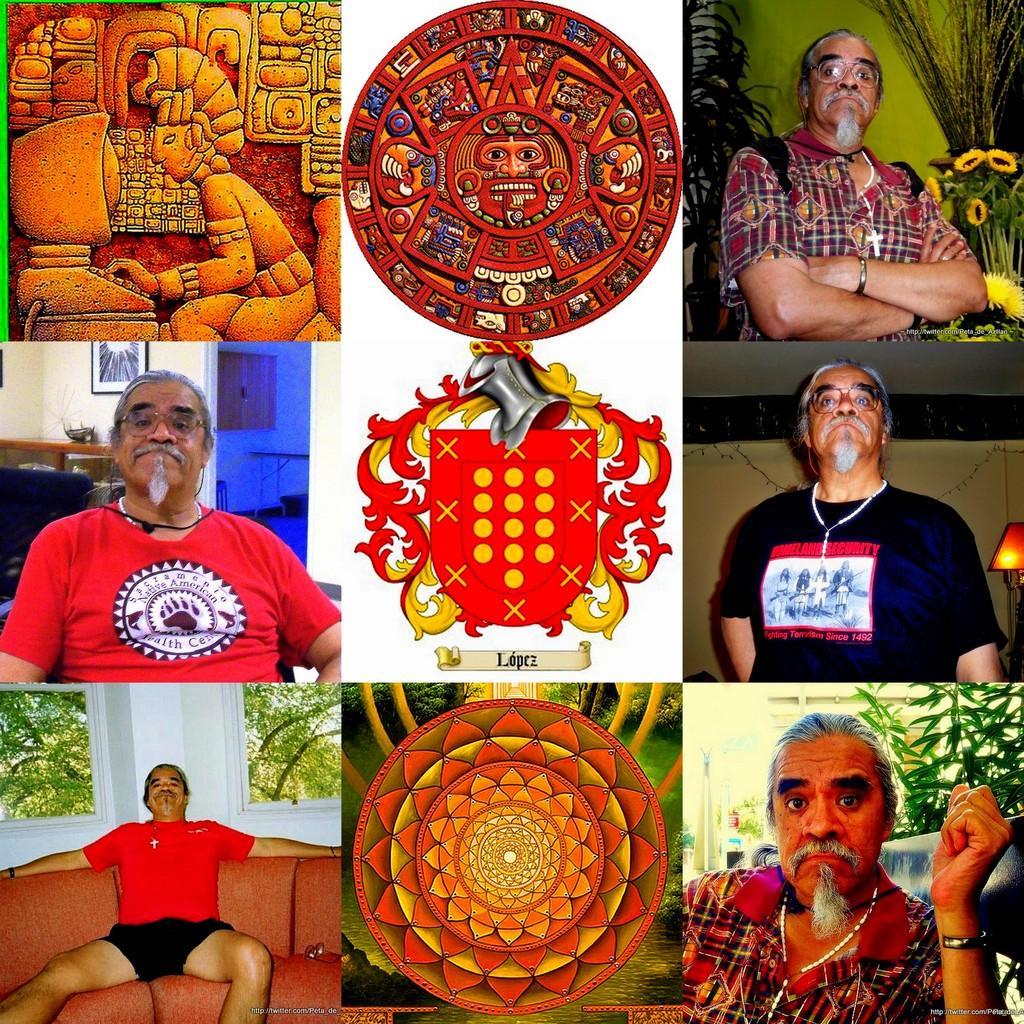Please provide a concise description of this image. This looks like an edited image. I can see a person standing and sitting. This is the couch. These are the two images of the ancient chakras. This looks like a logo. I think this is an ancient image. These are the windows. I can see the trees through the windows. This is the frame attached to the wall. 